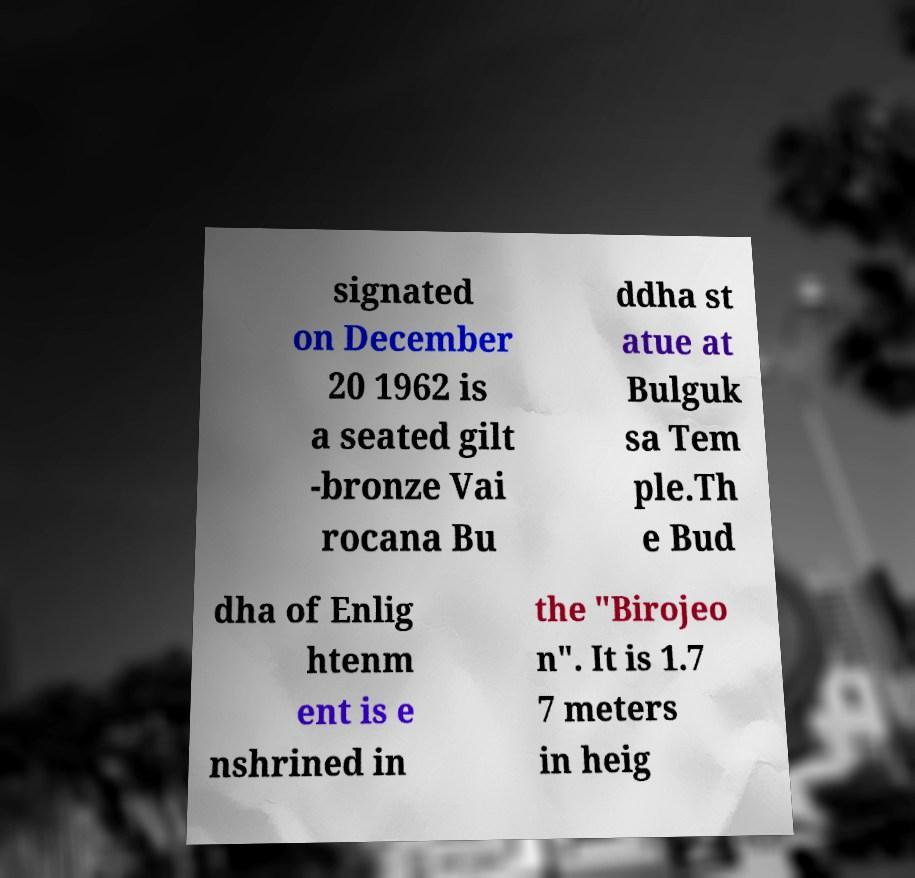Can you read and provide the text displayed in the image?This photo seems to have some interesting text. Can you extract and type it out for me? signated on December 20 1962 is a seated gilt -bronze Vai rocana Bu ddha st atue at Bulguk sa Tem ple.Th e Bud dha of Enlig htenm ent is e nshrined in the "Birojeo n". It is 1.7 7 meters in heig 